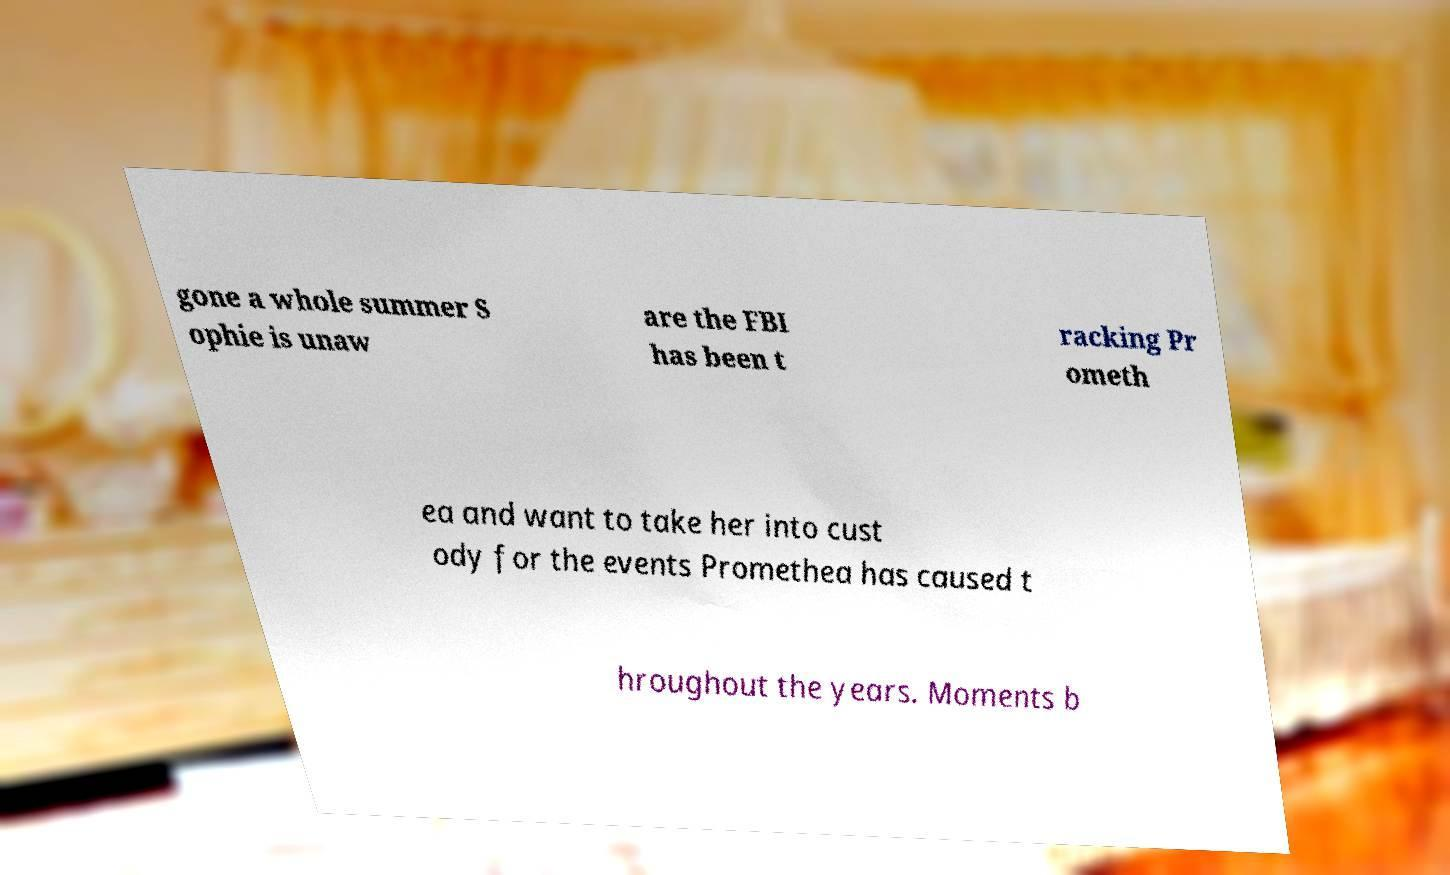Can you accurately transcribe the text from the provided image for me? gone a whole summer S ophie is unaw are the FBI has been t racking Pr ometh ea and want to take her into cust ody for the events Promethea has caused t hroughout the years. Moments b 